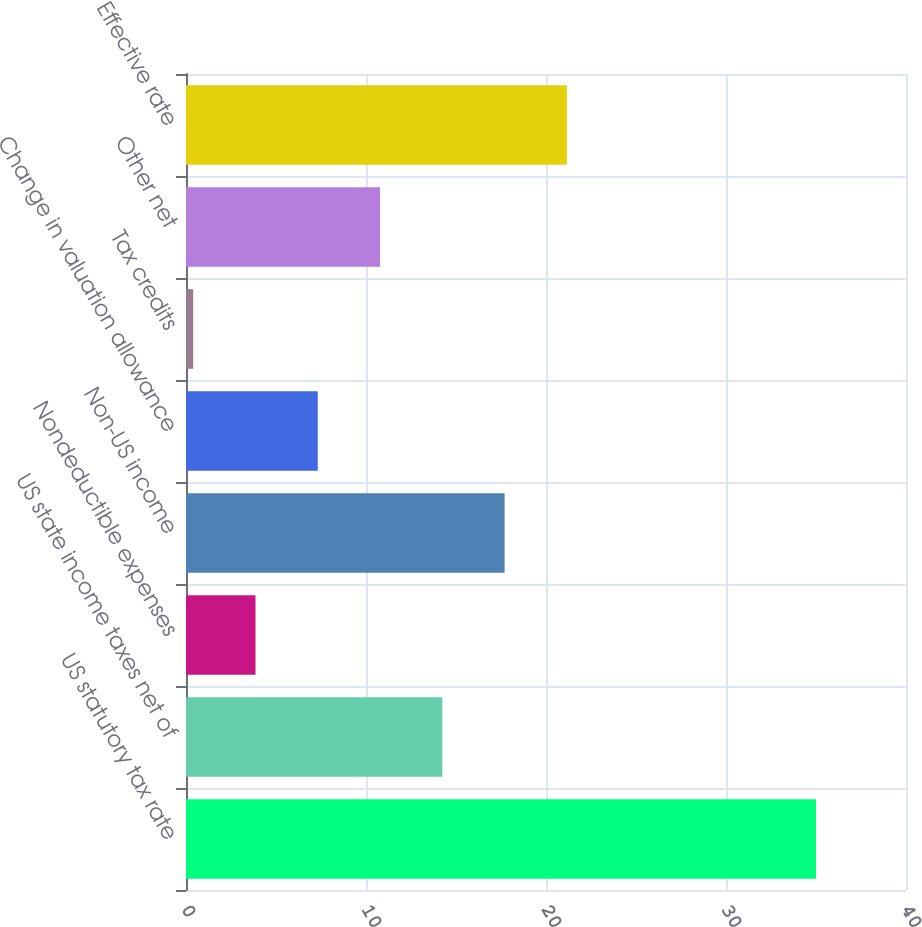Convert chart. <chart><loc_0><loc_0><loc_500><loc_500><bar_chart><fcel>US statutory tax rate<fcel>US state income taxes net of<fcel>Nondeductible expenses<fcel>Non-US income<fcel>Change in valuation allowance<fcel>Tax credits<fcel>Other net<fcel>Effective rate<nl><fcel>35<fcel>14.24<fcel>3.86<fcel>17.7<fcel>7.32<fcel>0.4<fcel>10.78<fcel>21.16<nl></chart> 